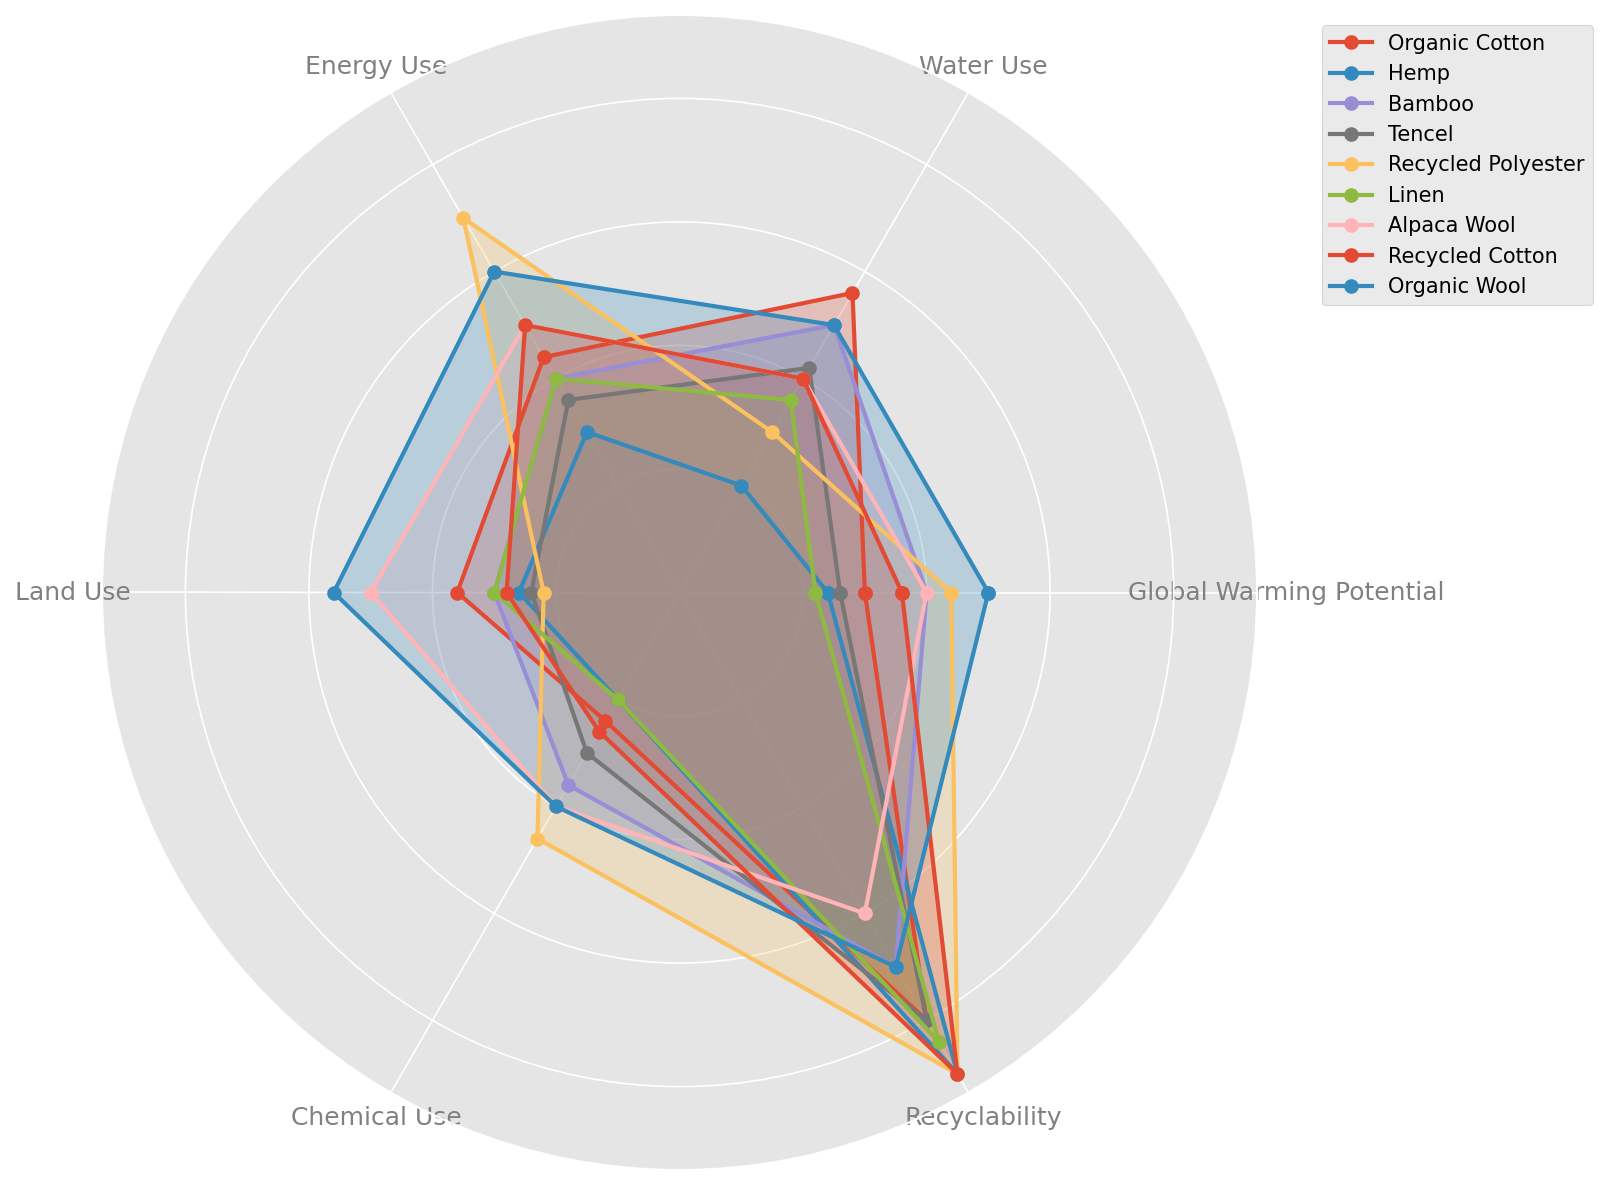Which fabric has the highest Recyclability score? First, find the Recyclability scores for each fabric. Then, identify the fabric with the highest score. Recycled Polyester, Hemp, and Recycled Cotton all have the highest score of 4.5.
Answer: Recycled Polyester, Hemp, and Recycled Cotton Which fabric uses the least amount of land? Check the Land Use scores for each fabric and find the one with the minimum value. Recycled Polyester has the lowest Land Use score of 1.1.
Answer: Recycled Polyester What is the difference between the Global Warming Potential scores of Tencel and Organic Wool? Look at the Global Warming Potential scores for Tencel and Organic Wool. Tencel scores 1.3 and Organic Wool scores 2.5. Subtract Tencel's score from Organic Wool's score: 2.5 - 1.3 = 1.2.
Answer: 1.2 Which fabric has the poorest performance in terms of Energy Use? Locate the Energy Use scores for each fabric and determine the highest score, which indicates the poorest performance. Recycled Polyester has the highest Energy Use score of 3.5.
Answer: Recycled Polyester Which fabrics have a Chemical Use score less than 1.5? Identify the Chemical Use scores and list the fabrics scoring lower than 1.5. Organic Cotton, Hemp, and Linen have Chemical Use scores of 1.2, 1.0, and 1.0 respectively.
Answer: Organic Cotton, Hemp, and Linen What is the average score of Water Use for Bamboo and Recycled Polyester? Find the Water Use scores for Bamboo and Recycled Polyester. Bamboo scores 2.5 and Recycled Polyester scores 1.5. Calculate the average: (2.5 + 1.5) / 2 = 2.0.
Answer: 2.0 Which fabric has the highest Global Warming Potential and what is its value? Locate the Global Warming Potential scores and find the highest value. Organic Wool has the highest Global Warming Potential score of 2.5.
Answer: Organic Wool, 2.5 How many fabrics have a Land Use score greater than 2? Check the Land Use scores for all fabrics and count how many have a score greater than 2. Only Alpaca Wool and Organic Wool have scores greater than 2.
Answer: 2 What is the sum of the Energy Use scores for Linen and Alpaca Wool? Find the Energy Use scores for Linen and Alpaca Wool. Linen scores 2.0 and Alpaca Wool scores 2.5. Add the scores: 2.0 + 2.5 = 4.5.
Answer: 4.5 